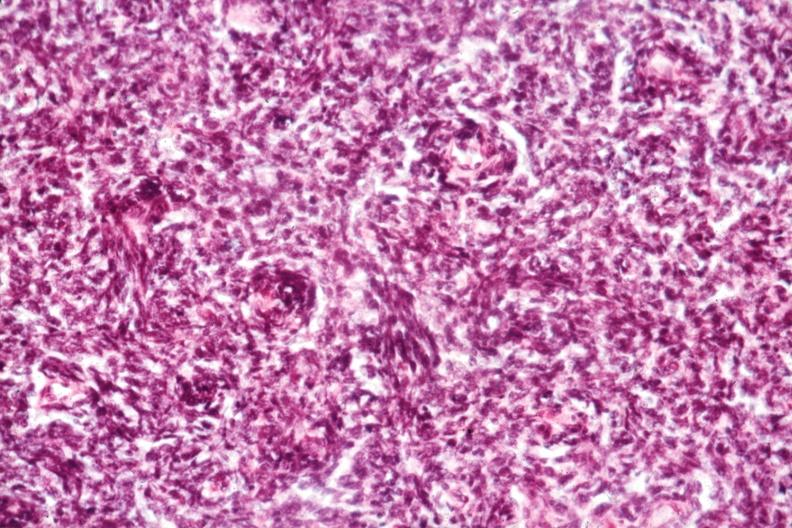what is present?
Answer the question using a single word or phrase. Malignant thymoma 